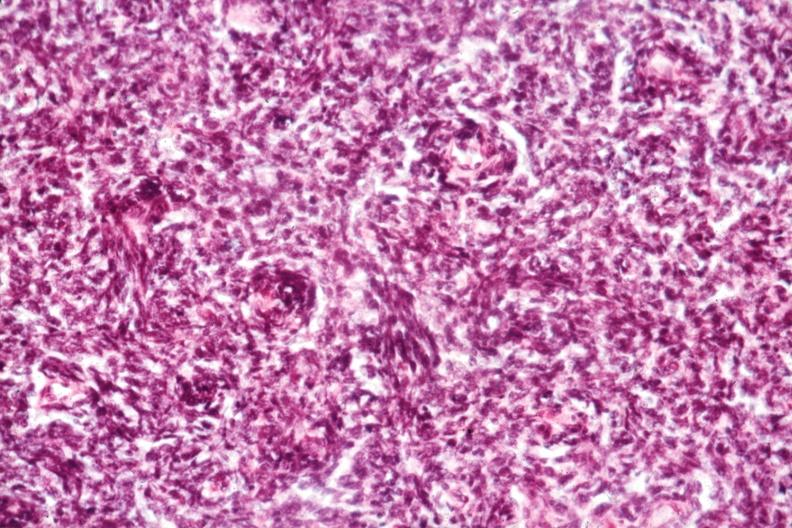what is present?
Answer the question using a single word or phrase. Malignant thymoma 